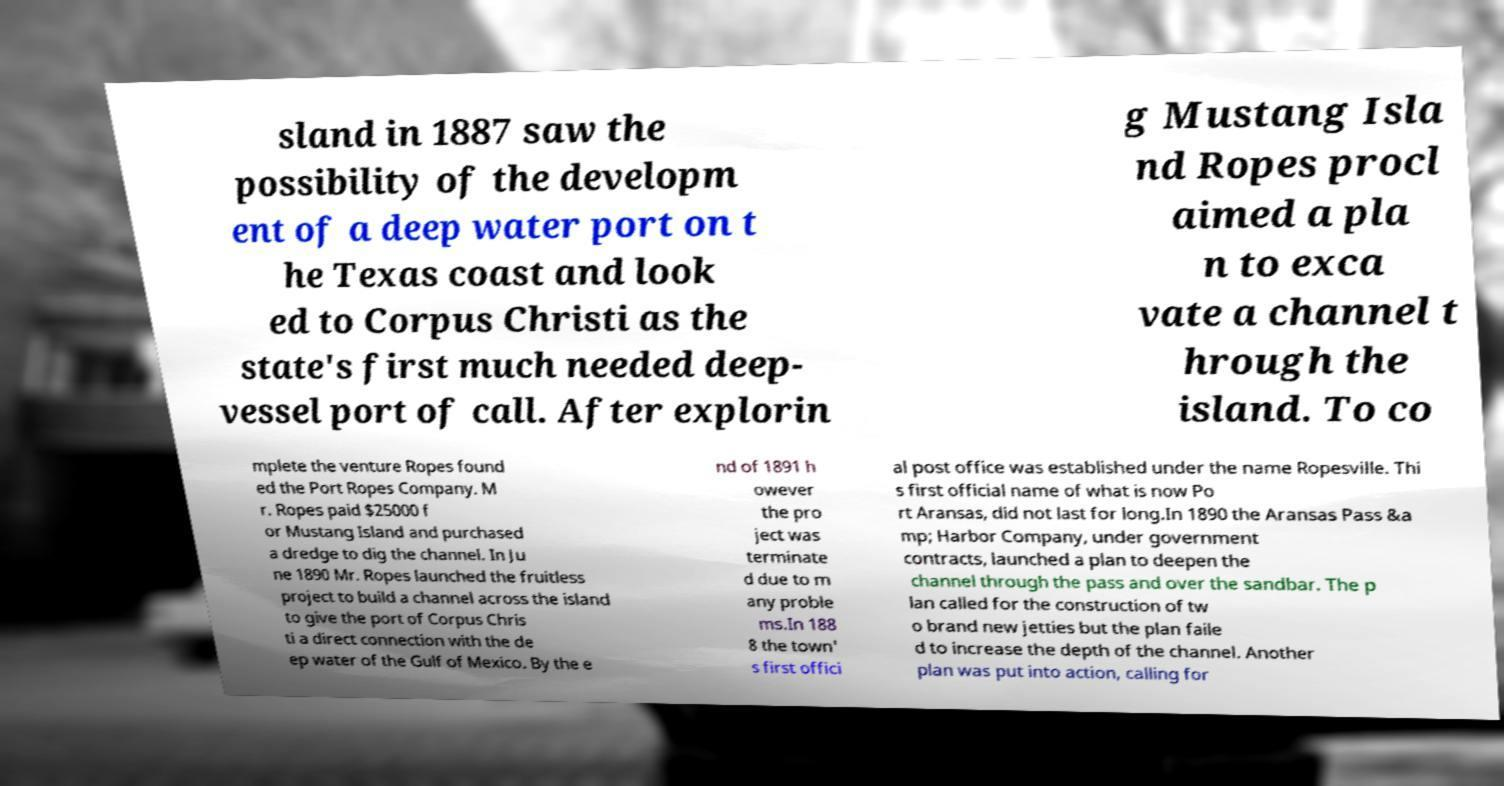There's text embedded in this image that I need extracted. Can you transcribe it verbatim? sland in 1887 saw the possibility of the developm ent of a deep water port on t he Texas coast and look ed to Corpus Christi as the state's first much needed deep- vessel port of call. After explorin g Mustang Isla nd Ropes procl aimed a pla n to exca vate a channel t hrough the island. To co mplete the venture Ropes found ed the Port Ropes Company. M r. Ropes paid $25000 f or Mustang Island and purchased a dredge to dig the channel. In Ju ne 1890 Mr. Ropes launched the fruitless project to build a channel across the island to give the port of Corpus Chris ti a direct connection with the de ep water of the Gulf of Mexico. By the e nd of 1891 h owever the pro ject was terminate d due to m any proble ms.In 188 8 the town' s first offici al post office was established under the name Ropesville. Thi s first official name of what is now Po rt Aransas, did not last for long.In 1890 the Aransas Pass &a mp; Harbor Company, under government contracts, launched a plan to deepen the channel through the pass and over the sandbar. The p lan called for the construction of tw o brand new jetties but the plan faile d to increase the depth of the channel. Another plan was put into action, calling for 